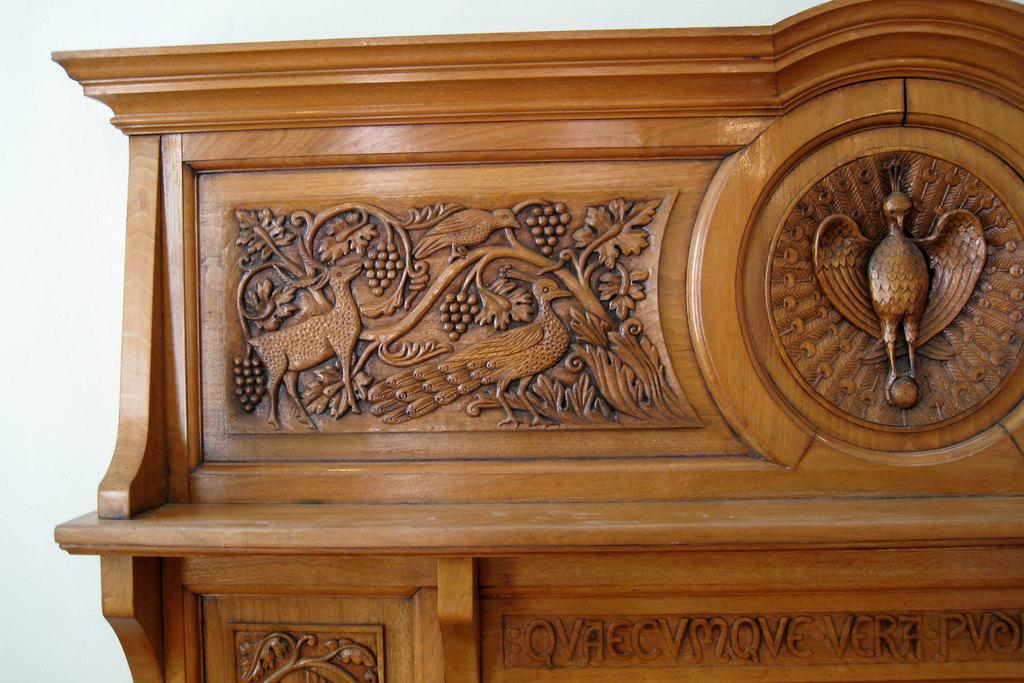What type of object can be seen in the image? There is a wooden carving in the image. What is the background of the image like? There is a plain wall in the image. Where is the faucet located in the image? There is no faucet present in the image. What type of beam is supporting the wooden carving in the image? There is no beam visible in the image, as the wooden carving is likely mounted on the plain wall. 